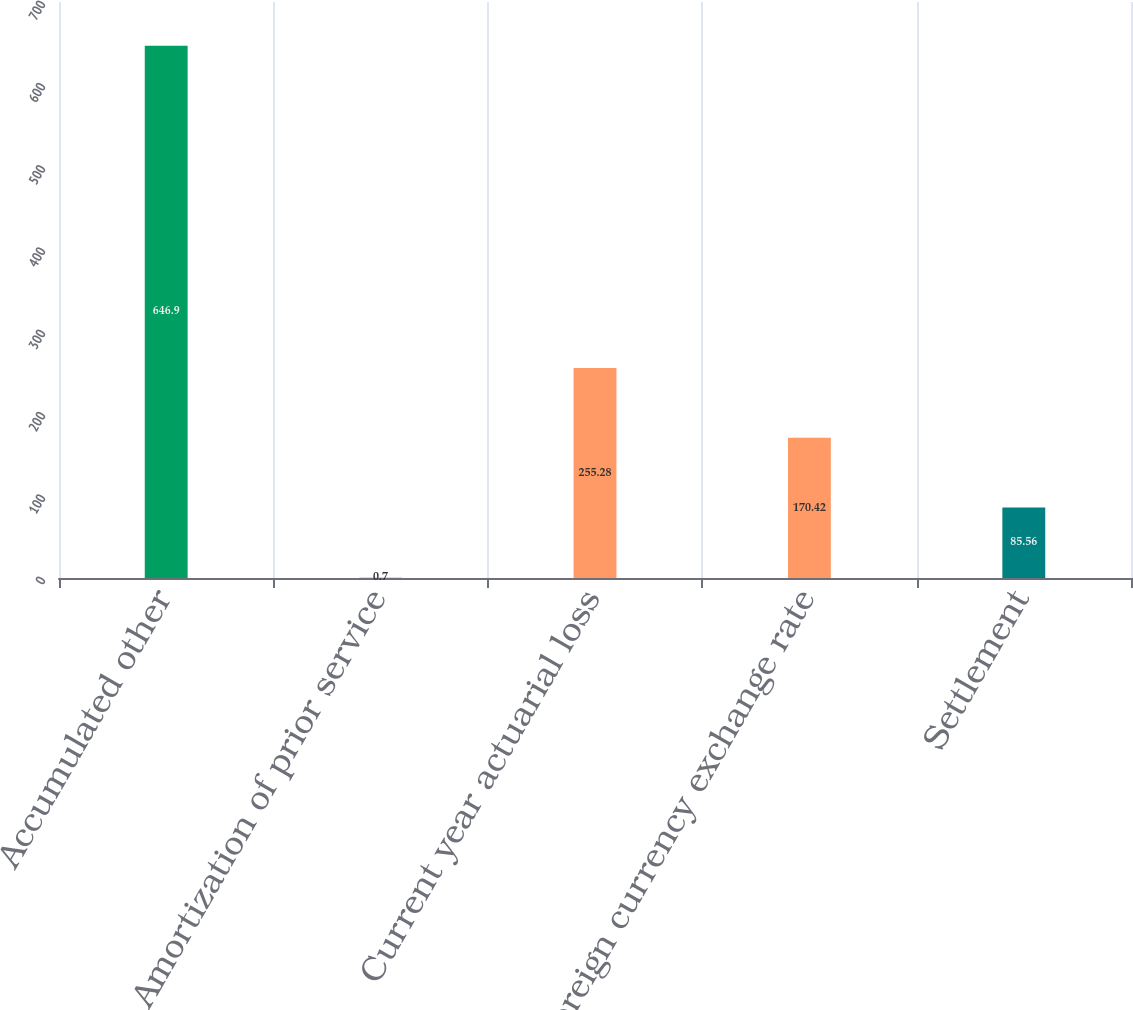Convert chart. <chart><loc_0><loc_0><loc_500><loc_500><bar_chart><fcel>Accumulated other<fcel>Amortization of prior service<fcel>Current year actuarial loss<fcel>Foreign currency exchange rate<fcel>Settlement<nl><fcel>646.9<fcel>0.7<fcel>255.28<fcel>170.42<fcel>85.56<nl></chart> 